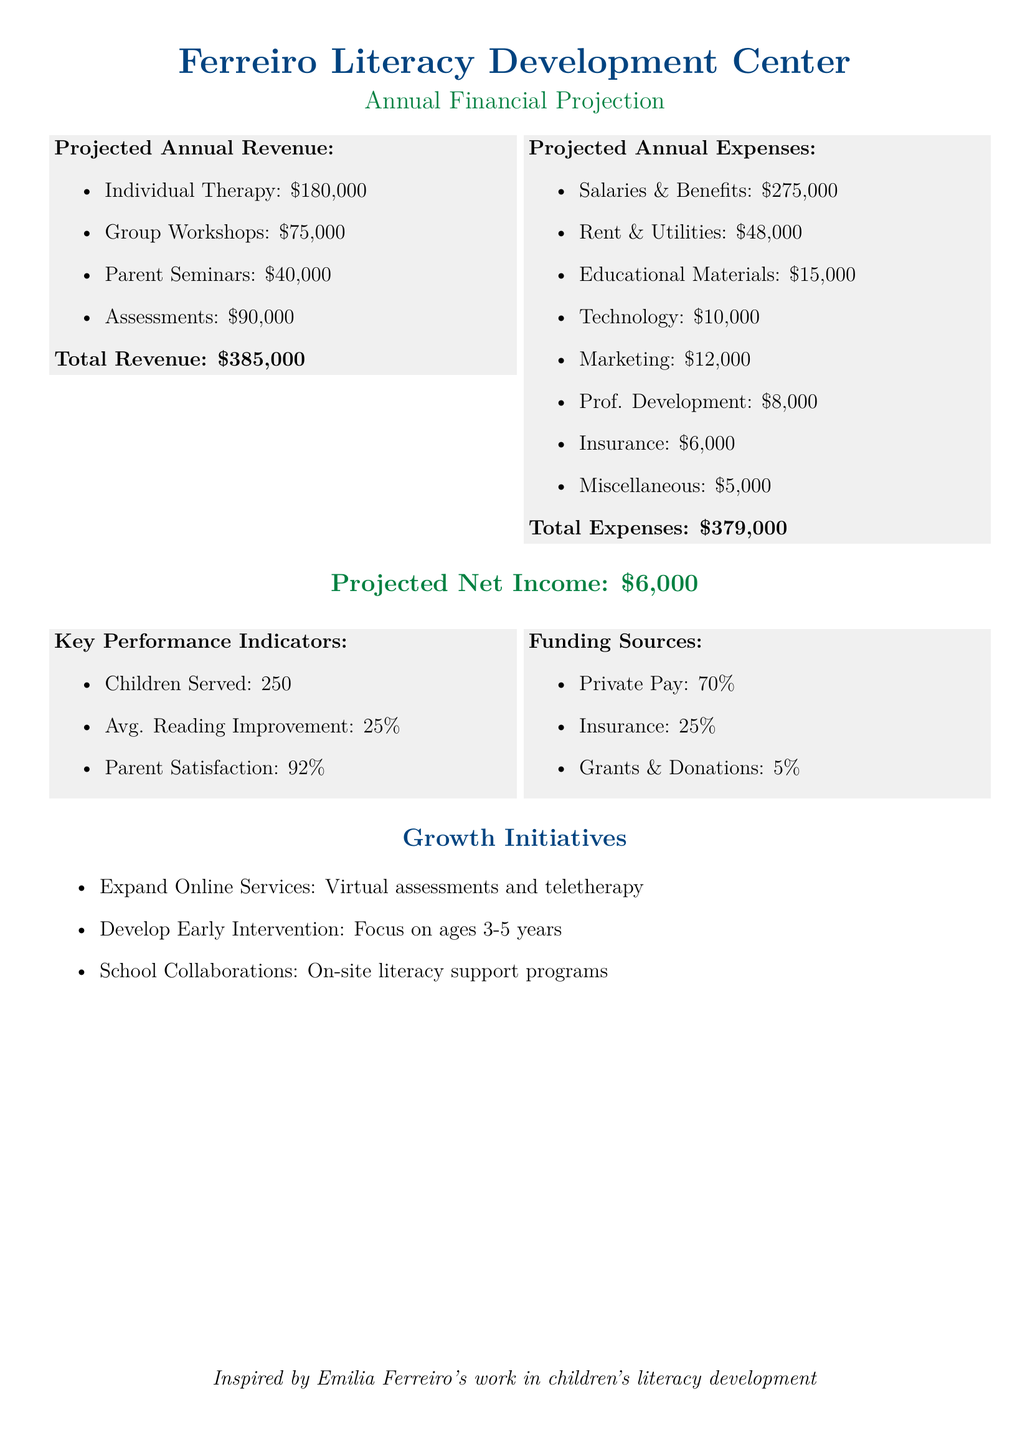What is the total revenue? The total revenue is the sum of all revenue sources in the document, which is $180,000 + $75,000 + $40,000 + $90,000 = $385,000.
Answer: $385,000 What are the salaries and benefits expenses? Salaries and benefits are listed as a specific expense in the document, which totals $275,000.
Answer: $275,000 How many children are served annually? The document specifies a key performance indicator, indicating that 250 children are served.
Answer: 250 What percentage of revenue comes from private pay? The funding sources section states that 70% of the revenue comes from private pay.
Answer: 70% What is the projected net income for the clinic? The projected net income is presented directly in the document as $6,000.
Answer: $6,000 What initiative focuses on ages 3-5 years? One of the growth initiatives in the document mentions developing early intervention for this age group.
Answer: Early Intervention What is the average reading improvement percentage? The document lists this as a key performance indicator which states an average reading improvement of 25%.
Answer: 25% What is the total for miscellaneous expenses? The miscellaneous expenses are documented at $5,000.
Answer: $5,000 How much is allocated for marketing? The marketing expense is specified in the document as $12,000.
Answer: $12,000 